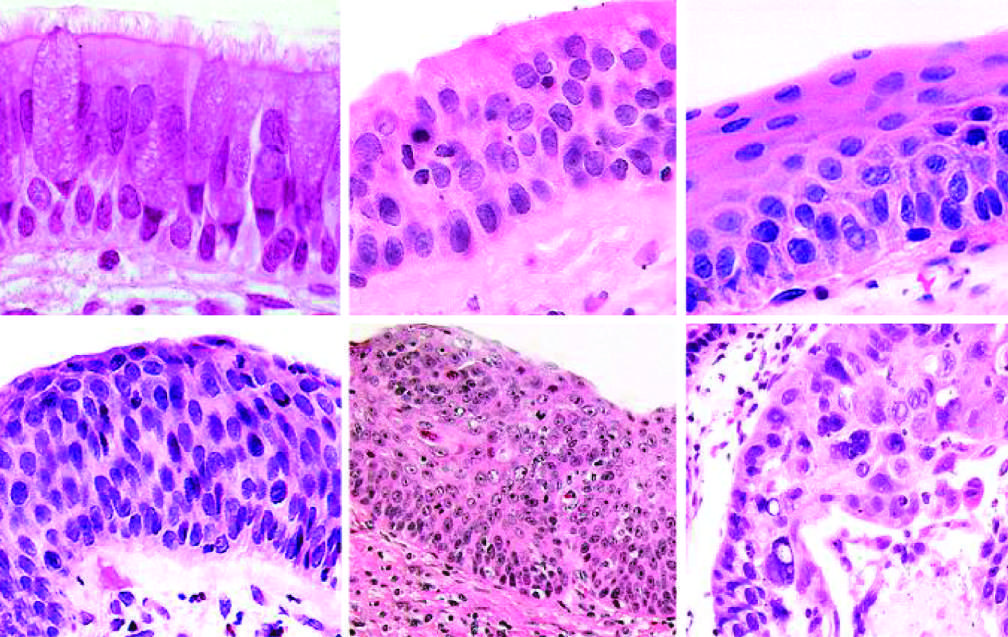what is carcinoma in situ?
Answer the question using a single word or phrase. The stage that immediately precedes invasive squamous cell carcinoma 